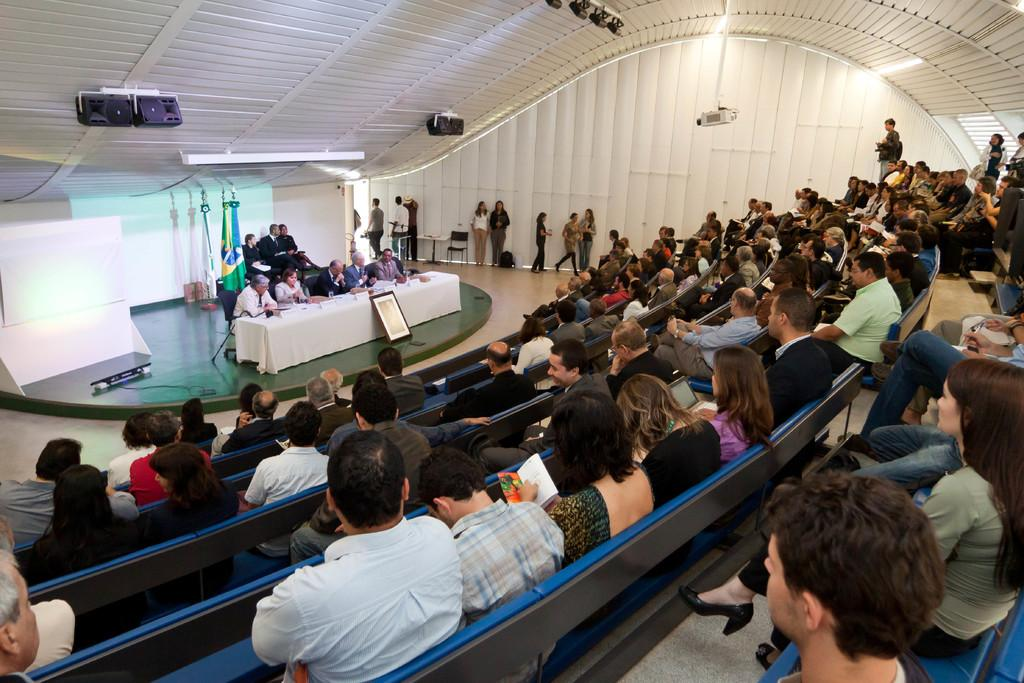What are the people in the image doing? The people in the image are sitting and listening to something. What can be seen behind the people in the image? There is a wall in the image, and it is white in color. Can you describe any objects visible on the rooftop? Yes, there are objects on the rooftop, but their specific nature is not mentioned in the facts. What might the people be listening to in the image? The facts do not specify what the people are listening to, so it cannot be determined from the image. What type of map can be seen on the arm of the person in the image? There is no map visible on the arm of any person in the image. What is the zephyr doing in the image? There is no mention of a zephyr in the image, as it is not a tangible object or living being. 